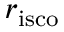Convert formula to latex. <formula><loc_0><loc_0><loc_500><loc_500>r _ { i s c o }</formula> 